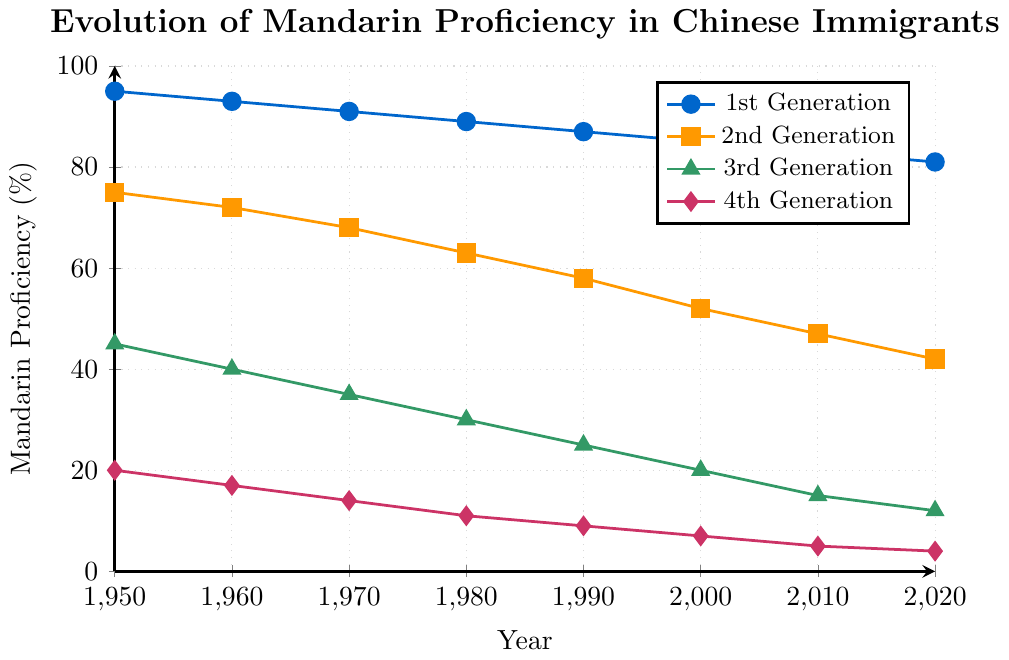What is the overall trend of Mandarin proficiency for the 1st generation of Chinese immigrants from 1950 to 2020? To determine the trend, examine the line representing the 1st generation. The proficiency starts at 95% in 1950 and decreases gradually to 81% in 2020. This indicates a declining trend over the period.
Answer: Decreasing How much did the Mandarin proficiency level decrease for the 2nd generation between 1960 and 2010? Look at the 2nd generation's proficiency levels in 1960 (72%) and 2010 (47%). Calculate the difference: 72 - 47 = 25.
Answer: 25 percentage points Which generation had the highest Mandarin proficiency in the year 2000? Examine the proficiency levels for the year 2000 across all generations. The 1st generation had 85%, which is the highest compared to the others.
Answer: 1st Generation How does the rate of decline in Mandarin proficiency compare between the 3rd generation and the 4th generation from 1950 to 2020? For the 3rd generation, proficiency drops from 45% to 12% (a decline of 33 percentage points). For the 4th generation, it drops from 20% to 4% (a decline of 16 percentage points). The 3rd generation shows a greater decline.
Answer: 3rd Generation declines faster In which decade did the 2nd generation experience the steepest decline in Mandarin proficiency? Calculate the decade-wise differences: 
1950-1960: 75-72=3 
1960-1970: 72-68=4 
1970-1980: 68-63=5 
1980-1990: 63-58=5 
1990-2000: 58-52=6 
2000-2010: 52-47=5 
2010-2020: 47-42=5
The steepest decline of 6 percentage points occurred between 1990 and 2000.
Answer: 1990-2000 By how many percentage points did the Mandarin proficiency of the 1st and 3rd generations differ in 1980? For 1980, the 1st generation's proficiency was 89% and the 3rd generation's was 30%. The difference is 89 - 30 = 59 percentage points.
Answer: 59 percentage points What is the average Mandarin proficiency of the 4th generation over the seven decades presented in the figure? List the proficiency levels for each decade: 20, 17, 14, 11, 9, 7, 5, 4. Summing these values gives 87. There are seven decades: 87/7 = 12.43.
Answer: 12.43% Which generation saw the least change in Mandarin proficiency from 1950 to 2020? Calculate the change for each generation: 
1st Generation: 95 - 81 = 14 
2nd Generation: 75 - 42 = 33 
3rd Generation: 45 - 12 = 33 
4th Generation: 20 - 4 = 16
The 1st generation had the least change of 14 percentage points.
Answer: 1st Generation What is the Mandarin proficiency difference between the 2nd and 4th generations in 1970? For 1970, the 2nd generation had a proficiency of 68% and the 4th generation had 14%. The difference is 68 - 14 = 54 percentage points.
Answer: 54 percentage points 